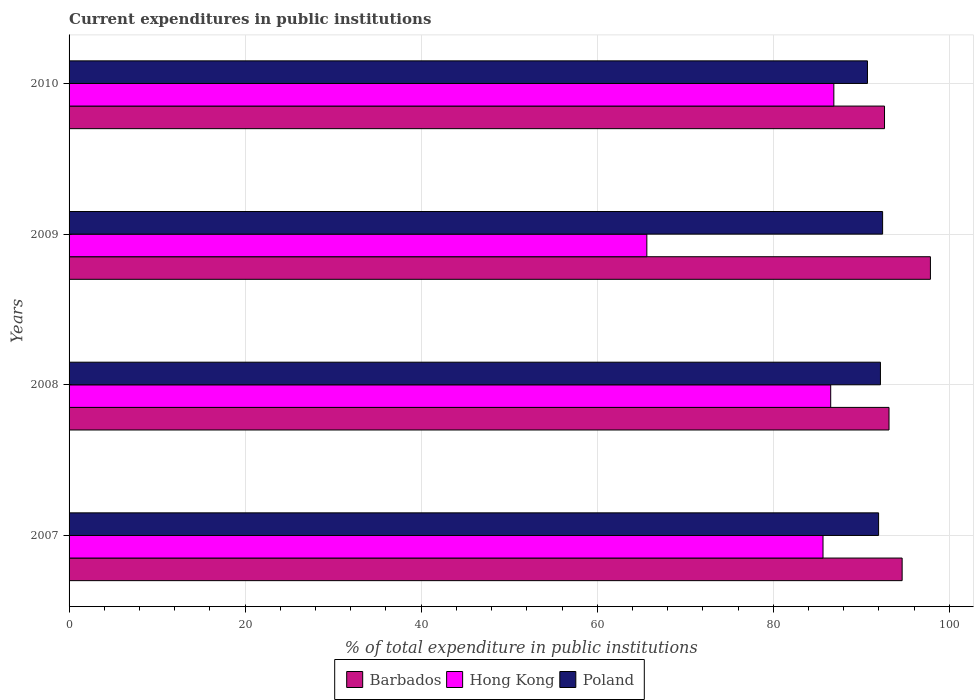Are the number of bars per tick equal to the number of legend labels?
Give a very brief answer. Yes. Are the number of bars on each tick of the Y-axis equal?
Your response must be concise. Yes. How many bars are there on the 4th tick from the top?
Provide a short and direct response. 3. What is the label of the 1st group of bars from the top?
Provide a succinct answer. 2010. In how many cases, is the number of bars for a given year not equal to the number of legend labels?
Provide a succinct answer. 0. What is the current expenditures in public institutions in Barbados in 2009?
Keep it short and to the point. 97.85. Across all years, what is the maximum current expenditures in public institutions in Hong Kong?
Make the answer very short. 86.88. Across all years, what is the minimum current expenditures in public institutions in Hong Kong?
Your answer should be very brief. 65.63. In which year was the current expenditures in public institutions in Barbados maximum?
Your response must be concise. 2009. What is the total current expenditures in public institutions in Barbados in the graph?
Your response must be concise. 378.25. What is the difference between the current expenditures in public institutions in Barbados in 2009 and that in 2010?
Ensure brevity in your answer.  5.22. What is the difference between the current expenditures in public institutions in Barbados in 2010 and the current expenditures in public institutions in Poland in 2007?
Your response must be concise. 0.67. What is the average current expenditures in public institutions in Hong Kong per year?
Offer a terse response. 81.17. In the year 2010, what is the difference between the current expenditures in public institutions in Barbados and current expenditures in public institutions in Hong Kong?
Your answer should be very brief. 5.75. What is the ratio of the current expenditures in public institutions in Barbados in 2007 to that in 2009?
Offer a very short reply. 0.97. Is the difference between the current expenditures in public institutions in Barbados in 2007 and 2008 greater than the difference between the current expenditures in public institutions in Hong Kong in 2007 and 2008?
Offer a terse response. Yes. What is the difference between the highest and the second highest current expenditures in public institutions in Barbados?
Your response must be concise. 3.21. What is the difference between the highest and the lowest current expenditures in public institutions in Barbados?
Ensure brevity in your answer.  5.22. Is the sum of the current expenditures in public institutions in Poland in 2008 and 2009 greater than the maximum current expenditures in public institutions in Barbados across all years?
Your answer should be compact. Yes. What does the 2nd bar from the top in 2008 represents?
Give a very brief answer. Hong Kong. What does the 2nd bar from the bottom in 2010 represents?
Your answer should be compact. Hong Kong. How many years are there in the graph?
Your answer should be very brief. 4. What is the difference between two consecutive major ticks on the X-axis?
Your response must be concise. 20. Are the values on the major ticks of X-axis written in scientific E-notation?
Your answer should be very brief. No. Does the graph contain any zero values?
Your answer should be very brief. No. Does the graph contain grids?
Offer a very short reply. Yes. Where does the legend appear in the graph?
Make the answer very short. Bottom center. What is the title of the graph?
Make the answer very short. Current expenditures in public institutions. What is the label or title of the X-axis?
Provide a succinct answer. % of total expenditure in public institutions. What is the label or title of the Y-axis?
Make the answer very short. Years. What is the % of total expenditure in public institutions of Barbados in 2007?
Give a very brief answer. 94.63. What is the % of total expenditure in public institutions of Hong Kong in 2007?
Ensure brevity in your answer.  85.65. What is the % of total expenditure in public institutions in Poland in 2007?
Your answer should be compact. 91.96. What is the % of total expenditure in public institutions of Barbados in 2008?
Your response must be concise. 93.14. What is the % of total expenditure in public institutions in Hong Kong in 2008?
Give a very brief answer. 86.52. What is the % of total expenditure in public institutions in Poland in 2008?
Offer a terse response. 92.17. What is the % of total expenditure in public institutions in Barbados in 2009?
Give a very brief answer. 97.85. What is the % of total expenditure in public institutions in Hong Kong in 2009?
Offer a terse response. 65.63. What is the % of total expenditure in public institutions of Poland in 2009?
Provide a short and direct response. 92.41. What is the % of total expenditure in public institutions in Barbados in 2010?
Your answer should be compact. 92.63. What is the % of total expenditure in public institutions in Hong Kong in 2010?
Provide a succinct answer. 86.88. What is the % of total expenditure in public institutions of Poland in 2010?
Give a very brief answer. 90.69. Across all years, what is the maximum % of total expenditure in public institutions of Barbados?
Ensure brevity in your answer.  97.85. Across all years, what is the maximum % of total expenditure in public institutions in Hong Kong?
Provide a short and direct response. 86.88. Across all years, what is the maximum % of total expenditure in public institutions of Poland?
Your response must be concise. 92.41. Across all years, what is the minimum % of total expenditure in public institutions of Barbados?
Provide a short and direct response. 92.63. Across all years, what is the minimum % of total expenditure in public institutions of Hong Kong?
Provide a short and direct response. 65.63. Across all years, what is the minimum % of total expenditure in public institutions of Poland?
Your answer should be very brief. 90.69. What is the total % of total expenditure in public institutions of Barbados in the graph?
Your answer should be very brief. 378.25. What is the total % of total expenditure in public institutions in Hong Kong in the graph?
Your response must be concise. 324.67. What is the total % of total expenditure in public institutions in Poland in the graph?
Your response must be concise. 367.23. What is the difference between the % of total expenditure in public institutions in Barbados in 2007 and that in 2008?
Provide a succinct answer. 1.49. What is the difference between the % of total expenditure in public institutions in Hong Kong in 2007 and that in 2008?
Keep it short and to the point. -0.87. What is the difference between the % of total expenditure in public institutions of Poland in 2007 and that in 2008?
Keep it short and to the point. -0.21. What is the difference between the % of total expenditure in public institutions of Barbados in 2007 and that in 2009?
Make the answer very short. -3.21. What is the difference between the % of total expenditure in public institutions in Hong Kong in 2007 and that in 2009?
Provide a succinct answer. 20.01. What is the difference between the % of total expenditure in public institutions of Poland in 2007 and that in 2009?
Keep it short and to the point. -0.46. What is the difference between the % of total expenditure in public institutions of Barbados in 2007 and that in 2010?
Your answer should be compact. 2. What is the difference between the % of total expenditure in public institutions in Hong Kong in 2007 and that in 2010?
Offer a terse response. -1.23. What is the difference between the % of total expenditure in public institutions of Poland in 2007 and that in 2010?
Your response must be concise. 1.26. What is the difference between the % of total expenditure in public institutions in Barbados in 2008 and that in 2009?
Your answer should be compact. -4.7. What is the difference between the % of total expenditure in public institutions in Hong Kong in 2008 and that in 2009?
Give a very brief answer. 20.89. What is the difference between the % of total expenditure in public institutions in Poland in 2008 and that in 2009?
Offer a very short reply. -0.25. What is the difference between the % of total expenditure in public institutions in Barbados in 2008 and that in 2010?
Your answer should be compact. 0.51. What is the difference between the % of total expenditure in public institutions in Hong Kong in 2008 and that in 2010?
Keep it short and to the point. -0.36. What is the difference between the % of total expenditure in public institutions in Poland in 2008 and that in 2010?
Give a very brief answer. 1.47. What is the difference between the % of total expenditure in public institutions in Barbados in 2009 and that in 2010?
Provide a succinct answer. 5.22. What is the difference between the % of total expenditure in public institutions in Hong Kong in 2009 and that in 2010?
Offer a very short reply. -21.24. What is the difference between the % of total expenditure in public institutions of Poland in 2009 and that in 2010?
Make the answer very short. 1.72. What is the difference between the % of total expenditure in public institutions of Barbados in 2007 and the % of total expenditure in public institutions of Hong Kong in 2008?
Keep it short and to the point. 8.12. What is the difference between the % of total expenditure in public institutions in Barbados in 2007 and the % of total expenditure in public institutions in Poland in 2008?
Provide a short and direct response. 2.47. What is the difference between the % of total expenditure in public institutions of Hong Kong in 2007 and the % of total expenditure in public institutions of Poland in 2008?
Your answer should be very brief. -6.52. What is the difference between the % of total expenditure in public institutions in Barbados in 2007 and the % of total expenditure in public institutions in Hong Kong in 2009?
Your response must be concise. 29. What is the difference between the % of total expenditure in public institutions of Barbados in 2007 and the % of total expenditure in public institutions of Poland in 2009?
Keep it short and to the point. 2.22. What is the difference between the % of total expenditure in public institutions of Hong Kong in 2007 and the % of total expenditure in public institutions of Poland in 2009?
Your answer should be very brief. -6.77. What is the difference between the % of total expenditure in public institutions of Barbados in 2007 and the % of total expenditure in public institutions of Hong Kong in 2010?
Offer a terse response. 7.76. What is the difference between the % of total expenditure in public institutions in Barbados in 2007 and the % of total expenditure in public institutions in Poland in 2010?
Your response must be concise. 3.94. What is the difference between the % of total expenditure in public institutions of Hong Kong in 2007 and the % of total expenditure in public institutions of Poland in 2010?
Offer a terse response. -5.05. What is the difference between the % of total expenditure in public institutions in Barbados in 2008 and the % of total expenditure in public institutions in Hong Kong in 2009?
Ensure brevity in your answer.  27.51. What is the difference between the % of total expenditure in public institutions of Barbados in 2008 and the % of total expenditure in public institutions of Poland in 2009?
Give a very brief answer. 0.73. What is the difference between the % of total expenditure in public institutions of Hong Kong in 2008 and the % of total expenditure in public institutions of Poland in 2009?
Your response must be concise. -5.9. What is the difference between the % of total expenditure in public institutions of Barbados in 2008 and the % of total expenditure in public institutions of Hong Kong in 2010?
Make the answer very short. 6.27. What is the difference between the % of total expenditure in public institutions in Barbados in 2008 and the % of total expenditure in public institutions in Poland in 2010?
Make the answer very short. 2.45. What is the difference between the % of total expenditure in public institutions of Hong Kong in 2008 and the % of total expenditure in public institutions of Poland in 2010?
Offer a terse response. -4.18. What is the difference between the % of total expenditure in public institutions of Barbados in 2009 and the % of total expenditure in public institutions of Hong Kong in 2010?
Keep it short and to the point. 10.97. What is the difference between the % of total expenditure in public institutions in Barbados in 2009 and the % of total expenditure in public institutions in Poland in 2010?
Your answer should be very brief. 7.15. What is the difference between the % of total expenditure in public institutions of Hong Kong in 2009 and the % of total expenditure in public institutions of Poland in 2010?
Your answer should be very brief. -25.06. What is the average % of total expenditure in public institutions of Barbados per year?
Give a very brief answer. 94.56. What is the average % of total expenditure in public institutions of Hong Kong per year?
Make the answer very short. 81.17. What is the average % of total expenditure in public institutions of Poland per year?
Your answer should be very brief. 91.81. In the year 2007, what is the difference between the % of total expenditure in public institutions of Barbados and % of total expenditure in public institutions of Hong Kong?
Offer a very short reply. 8.99. In the year 2007, what is the difference between the % of total expenditure in public institutions of Barbados and % of total expenditure in public institutions of Poland?
Give a very brief answer. 2.68. In the year 2007, what is the difference between the % of total expenditure in public institutions in Hong Kong and % of total expenditure in public institutions in Poland?
Make the answer very short. -6.31. In the year 2008, what is the difference between the % of total expenditure in public institutions of Barbados and % of total expenditure in public institutions of Hong Kong?
Your answer should be compact. 6.63. In the year 2008, what is the difference between the % of total expenditure in public institutions in Barbados and % of total expenditure in public institutions in Poland?
Your answer should be very brief. 0.98. In the year 2008, what is the difference between the % of total expenditure in public institutions of Hong Kong and % of total expenditure in public institutions of Poland?
Your answer should be very brief. -5.65. In the year 2009, what is the difference between the % of total expenditure in public institutions of Barbados and % of total expenditure in public institutions of Hong Kong?
Provide a short and direct response. 32.21. In the year 2009, what is the difference between the % of total expenditure in public institutions of Barbados and % of total expenditure in public institutions of Poland?
Your answer should be very brief. 5.43. In the year 2009, what is the difference between the % of total expenditure in public institutions in Hong Kong and % of total expenditure in public institutions in Poland?
Offer a terse response. -26.78. In the year 2010, what is the difference between the % of total expenditure in public institutions in Barbados and % of total expenditure in public institutions in Hong Kong?
Your answer should be compact. 5.75. In the year 2010, what is the difference between the % of total expenditure in public institutions in Barbados and % of total expenditure in public institutions in Poland?
Ensure brevity in your answer.  1.94. In the year 2010, what is the difference between the % of total expenditure in public institutions of Hong Kong and % of total expenditure in public institutions of Poland?
Ensure brevity in your answer.  -3.82. What is the ratio of the % of total expenditure in public institutions in Barbados in 2007 to that in 2008?
Give a very brief answer. 1.02. What is the ratio of the % of total expenditure in public institutions in Hong Kong in 2007 to that in 2008?
Your response must be concise. 0.99. What is the ratio of the % of total expenditure in public institutions of Poland in 2007 to that in 2008?
Provide a short and direct response. 1. What is the ratio of the % of total expenditure in public institutions in Barbados in 2007 to that in 2009?
Give a very brief answer. 0.97. What is the ratio of the % of total expenditure in public institutions of Hong Kong in 2007 to that in 2009?
Offer a very short reply. 1.3. What is the ratio of the % of total expenditure in public institutions in Poland in 2007 to that in 2009?
Your answer should be compact. 1. What is the ratio of the % of total expenditure in public institutions of Barbados in 2007 to that in 2010?
Provide a short and direct response. 1.02. What is the ratio of the % of total expenditure in public institutions in Hong Kong in 2007 to that in 2010?
Offer a very short reply. 0.99. What is the ratio of the % of total expenditure in public institutions of Poland in 2007 to that in 2010?
Offer a terse response. 1.01. What is the ratio of the % of total expenditure in public institutions of Barbados in 2008 to that in 2009?
Offer a terse response. 0.95. What is the ratio of the % of total expenditure in public institutions of Hong Kong in 2008 to that in 2009?
Your answer should be very brief. 1.32. What is the ratio of the % of total expenditure in public institutions of Poland in 2008 to that in 2009?
Offer a very short reply. 1. What is the ratio of the % of total expenditure in public institutions in Barbados in 2008 to that in 2010?
Provide a short and direct response. 1.01. What is the ratio of the % of total expenditure in public institutions of Hong Kong in 2008 to that in 2010?
Make the answer very short. 1. What is the ratio of the % of total expenditure in public institutions of Poland in 2008 to that in 2010?
Provide a succinct answer. 1.02. What is the ratio of the % of total expenditure in public institutions of Barbados in 2009 to that in 2010?
Ensure brevity in your answer.  1.06. What is the ratio of the % of total expenditure in public institutions in Hong Kong in 2009 to that in 2010?
Offer a terse response. 0.76. What is the ratio of the % of total expenditure in public institutions in Poland in 2009 to that in 2010?
Keep it short and to the point. 1.02. What is the difference between the highest and the second highest % of total expenditure in public institutions of Barbados?
Your answer should be compact. 3.21. What is the difference between the highest and the second highest % of total expenditure in public institutions of Hong Kong?
Your answer should be very brief. 0.36. What is the difference between the highest and the second highest % of total expenditure in public institutions of Poland?
Your answer should be very brief. 0.25. What is the difference between the highest and the lowest % of total expenditure in public institutions in Barbados?
Give a very brief answer. 5.22. What is the difference between the highest and the lowest % of total expenditure in public institutions in Hong Kong?
Provide a succinct answer. 21.24. What is the difference between the highest and the lowest % of total expenditure in public institutions in Poland?
Your answer should be very brief. 1.72. 